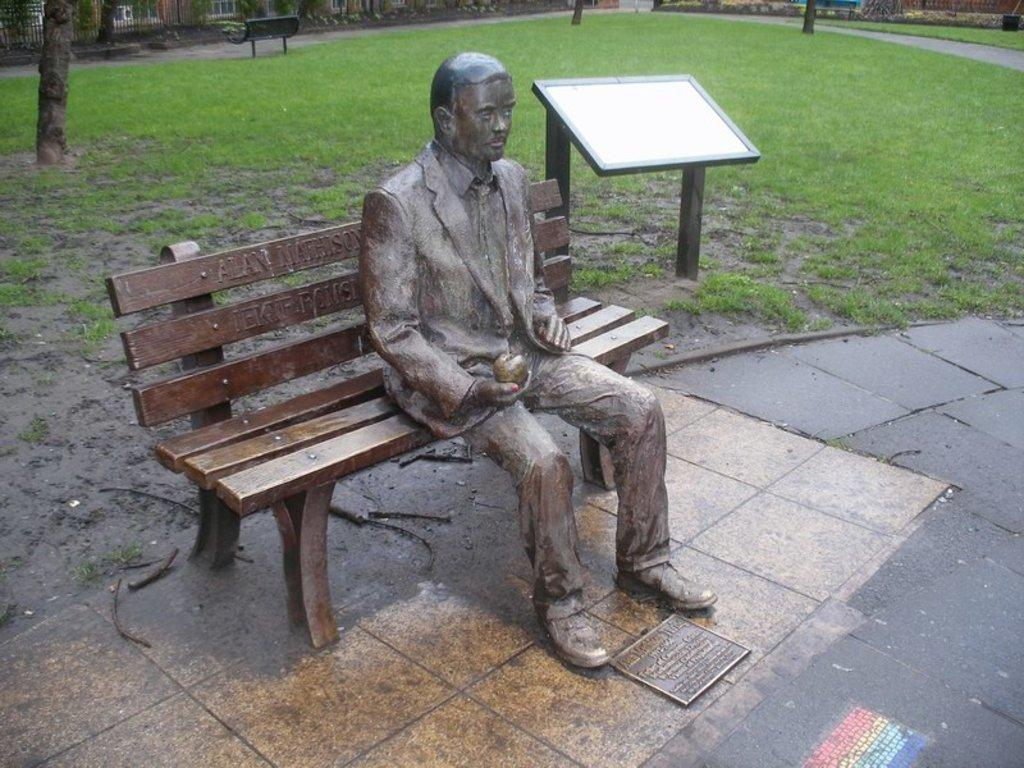What is the man in the image doing? The man is sitting on a bench in the image. What type of vegetation is present in the image? There is grass in the image. What other natural element can be seen in the image? There is a tree in the image. What spark caused the tree to catch fire in the image? There is no spark or fire present in the image; the tree is not on fire. 